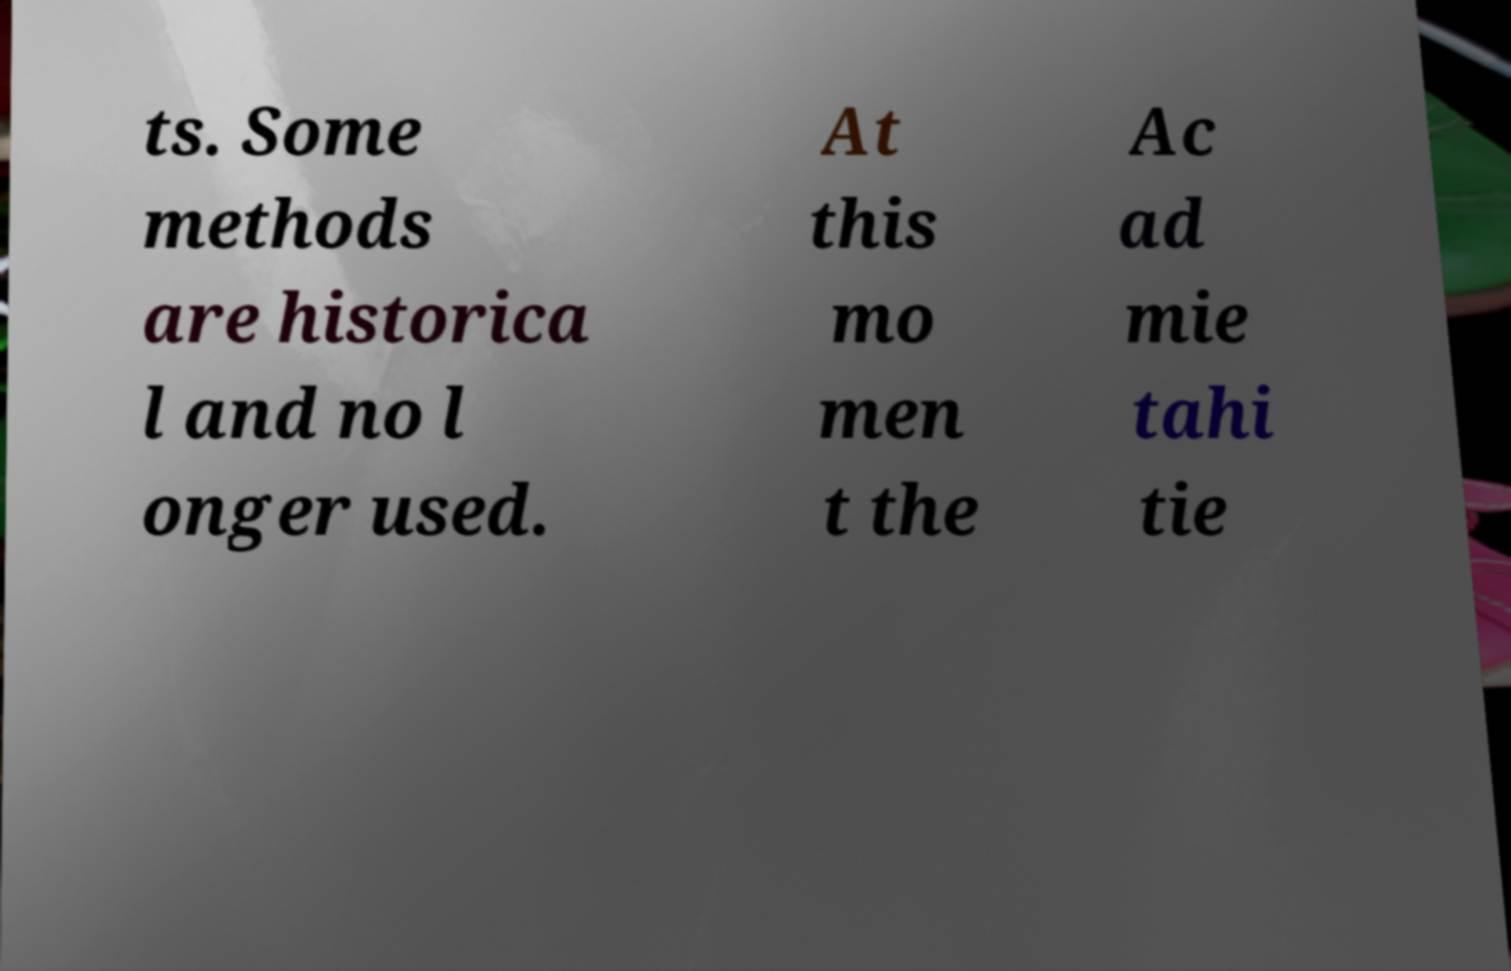Can you accurately transcribe the text from the provided image for me? ts. Some methods are historica l and no l onger used. At this mo men t the Ac ad mie tahi tie 